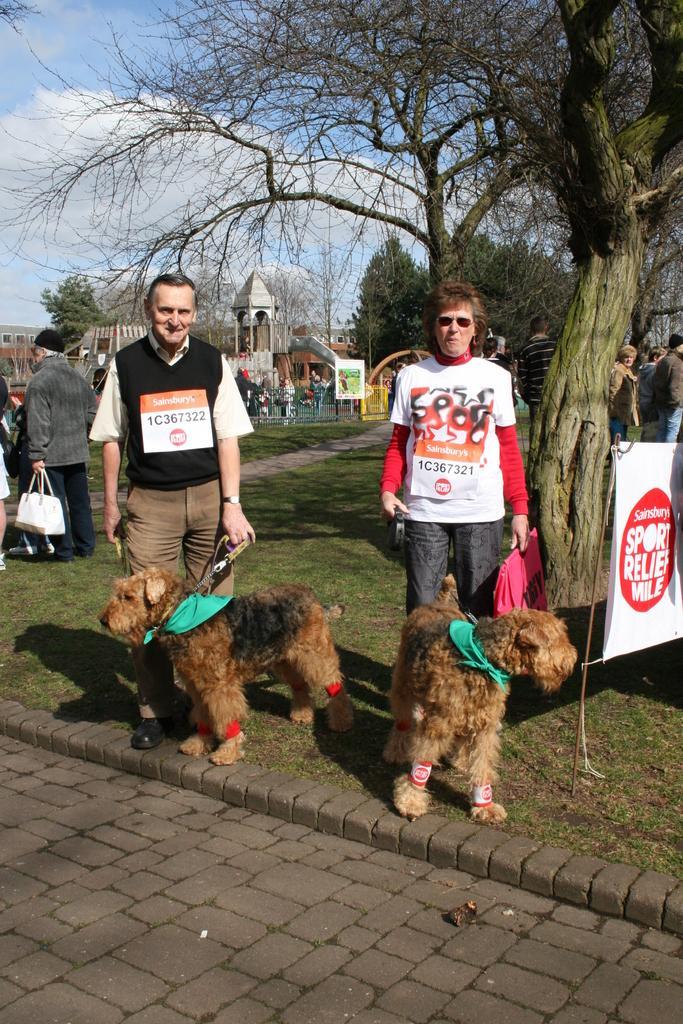Please provide a concise description of this image. This picture is of outside. On the right corner there is a tree and a banner placed on the ground. In the center there is a man wearing white color t-shirt and holding a bag and there are two dogs standing on the ground and on the left there is a man standing on the ground. In the left corner there is a person standing and holding a bag. In the background we can see the group of people, a building and a sky full of clouds. 